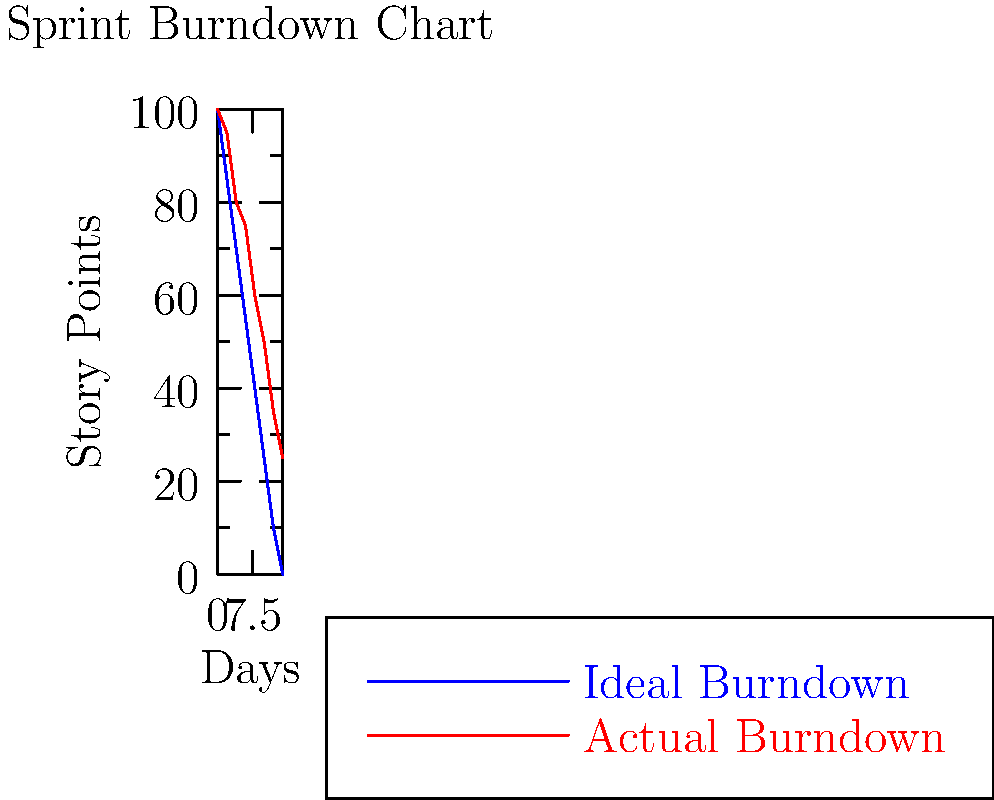As a managerial professional reviewing the sprint burndown chart provided by your senior engineer, what conclusion can you draw about the project's progress compared to the ideal burndown, and what action might you need to consider? To interpret this burndown chart and draw a conclusion, let's follow these steps:

1. Understand the chart components:
   - Blue line: Ideal burndown (expected progress)
   - Red line: Actual burndown (real progress)
   - X-axis: Days of the sprint
   - Y-axis: Remaining story points

2. Compare the actual burndown to the ideal burndown:
   - The actual (red) line is consistently above the ideal (blue) line
   - This indicates that the team is completing fewer story points than planned

3. Analyze the gap between actual and ideal:
   - The gap widens as the sprint progresses
   - By the end of the sprint (day 14), there's a significant difference

4. Interpret the end state:
   - The ideal burndown reaches 0 story points
   - The actual burndown ends at about 25 story points

5. Draw a conclusion:
   - The project is behind schedule
   - The team is not likely to complete all planned work in this sprint

6. Consider potential actions:
   - Discuss with the senior engineer about obstacles or challenges
   - Potentially adjust the sprint scope or extend the timeline
   - Plan for carrying over unfinished work to the next sprint

Given your persona as a managerial professional relying on the senior engineer, you should consider discussing the reasons for the delay and potential solutions with your senior engineer.
Answer: The project is behind schedule; discuss challenges and potential adjustments with the senior engineer. 